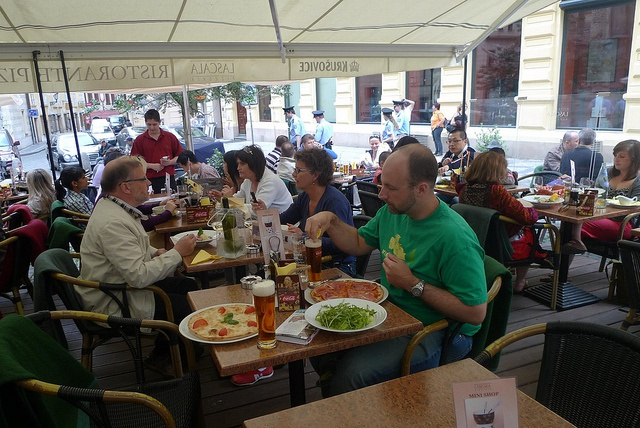Describe the objects in this image and their specific colors. I can see chair in darkgray, black, olive, and gray tones, people in darkgray, black, darkgreen, and maroon tones, people in darkgray, black, and gray tones, chair in darkgray, black, and gray tones, and dining table in darkgray, gray, and maroon tones in this image. 